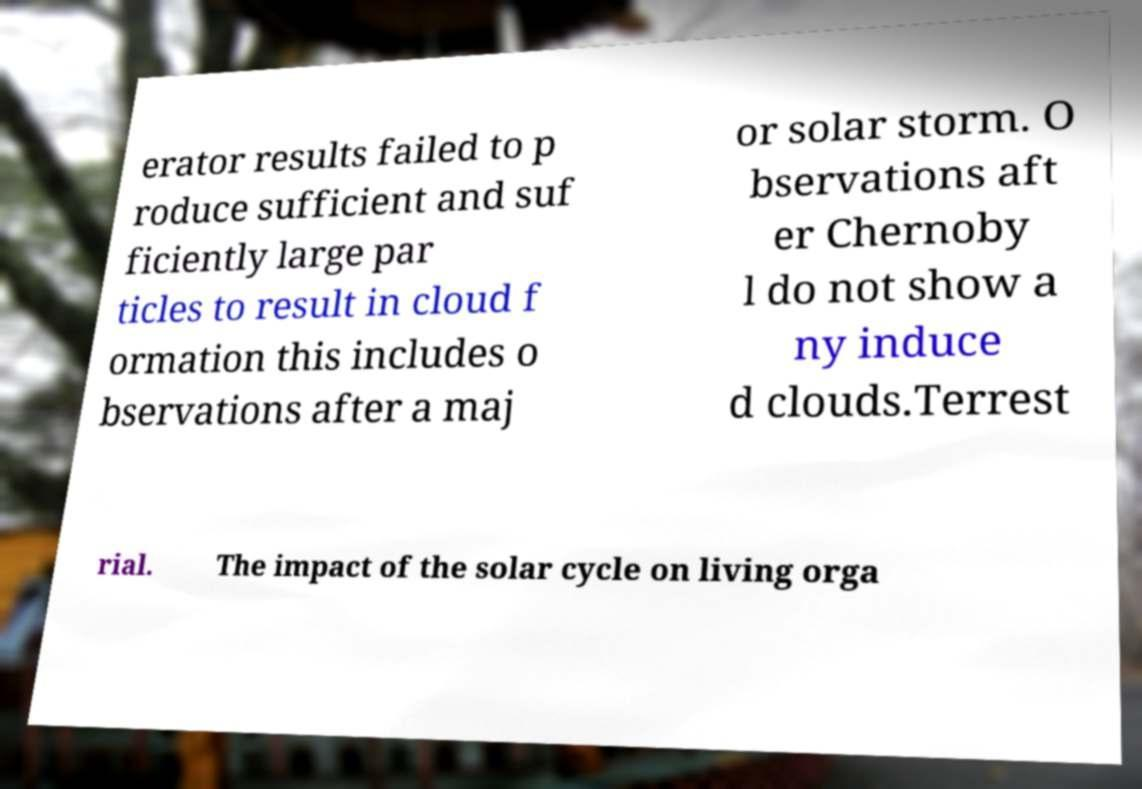Please identify and transcribe the text found in this image. erator results failed to p roduce sufficient and suf ficiently large par ticles to result in cloud f ormation this includes o bservations after a maj or solar storm. O bservations aft er Chernoby l do not show a ny induce d clouds.Terrest rial. The impact of the solar cycle on living orga 